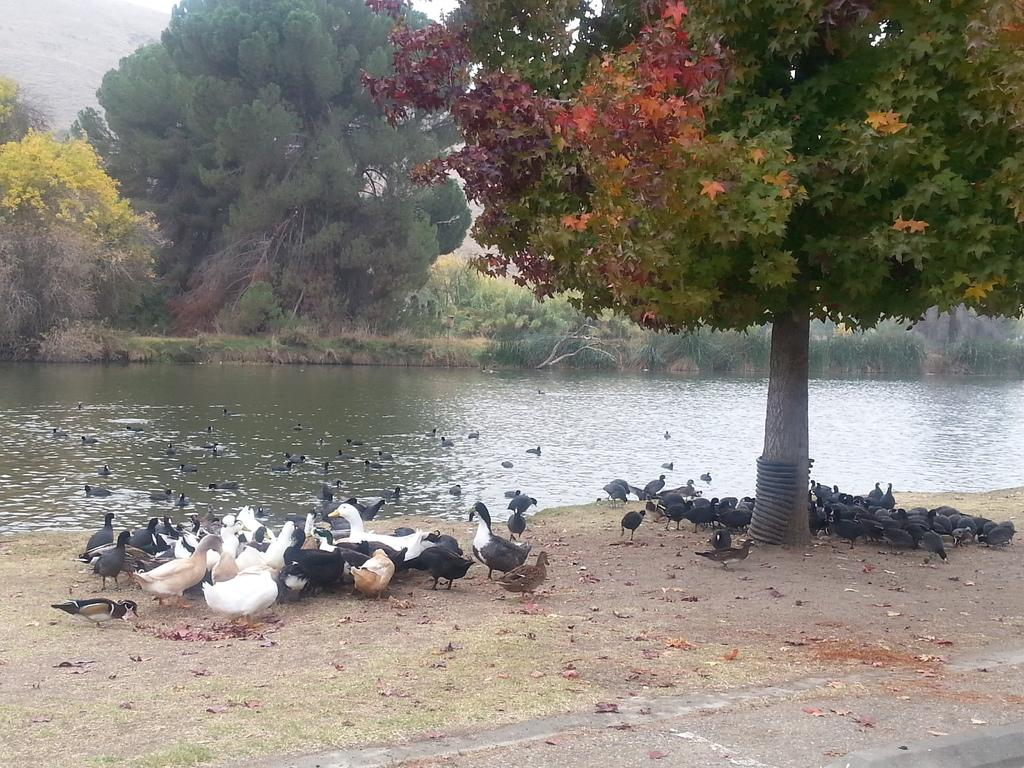What type of natural elements can be seen in the image? There are trees and water visible in the image. What type of animals are present in the image? There are birds in the image. Can you describe the coloring of the birds? The birds have black, brown, and white coloring. What type of appliance can be seen in the image? There is no appliance present in the image. How many dimes are visible in the image? There are no dimes present in the image. 